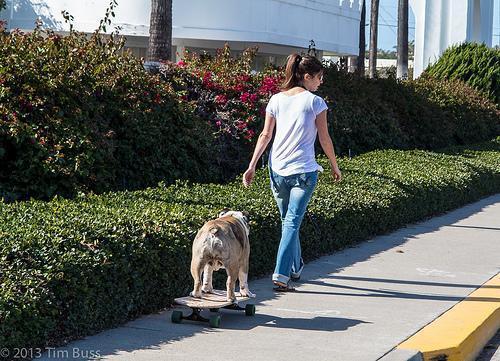How many dogs are shown?
Give a very brief answer. 1. How many wheels on the skateboard are visible?
Give a very brief answer. 4. 